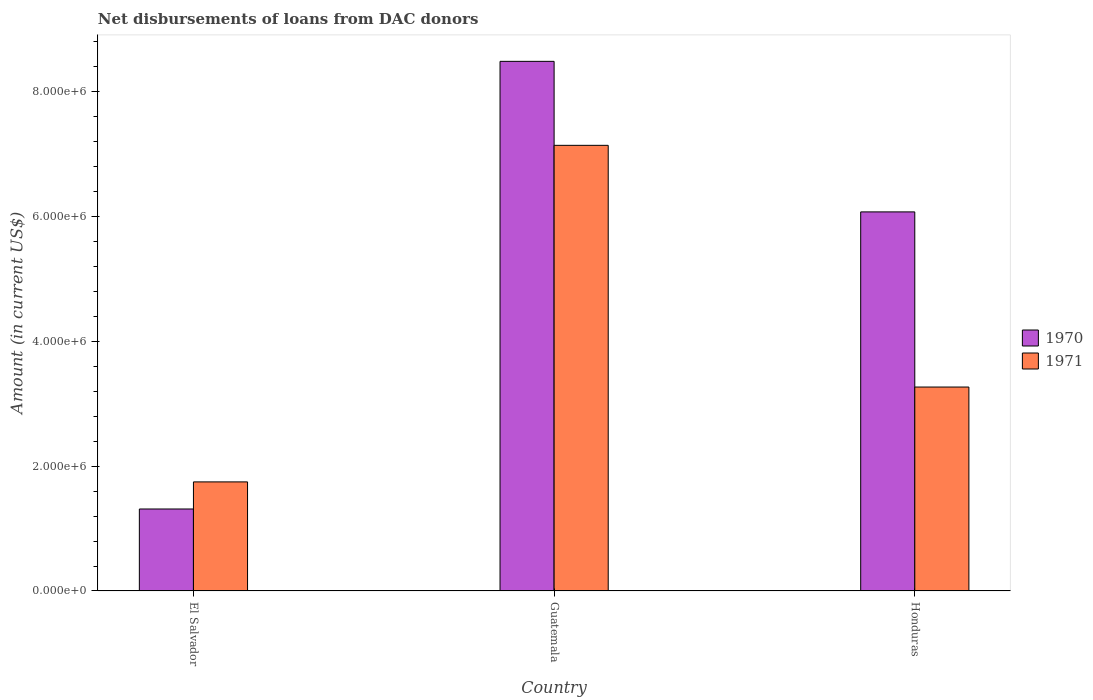How many different coloured bars are there?
Provide a succinct answer. 2. What is the label of the 3rd group of bars from the left?
Offer a terse response. Honduras. In how many cases, is the number of bars for a given country not equal to the number of legend labels?
Provide a short and direct response. 0. What is the amount of loans disbursed in 1971 in El Salvador?
Provide a short and direct response. 1.75e+06. Across all countries, what is the maximum amount of loans disbursed in 1970?
Your answer should be compact. 8.48e+06. Across all countries, what is the minimum amount of loans disbursed in 1970?
Provide a short and direct response. 1.31e+06. In which country was the amount of loans disbursed in 1971 maximum?
Your answer should be very brief. Guatemala. In which country was the amount of loans disbursed in 1970 minimum?
Give a very brief answer. El Salvador. What is the total amount of loans disbursed in 1970 in the graph?
Keep it short and to the point. 1.59e+07. What is the difference between the amount of loans disbursed in 1971 in El Salvador and that in Guatemala?
Provide a short and direct response. -5.39e+06. What is the difference between the amount of loans disbursed in 1971 in El Salvador and the amount of loans disbursed in 1970 in Guatemala?
Make the answer very short. -6.74e+06. What is the average amount of loans disbursed in 1971 per country?
Provide a succinct answer. 4.05e+06. What is the difference between the amount of loans disbursed of/in 1971 and amount of loans disbursed of/in 1970 in Guatemala?
Ensure brevity in your answer.  -1.34e+06. What is the ratio of the amount of loans disbursed in 1970 in El Salvador to that in Guatemala?
Make the answer very short. 0.15. Is the amount of loans disbursed in 1970 in El Salvador less than that in Honduras?
Your answer should be very brief. Yes. Is the difference between the amount of loans disbursed in 1971 in El Salvador and Honduras greater than the difference between the amount of loans disbursed in 1970 in El Salvador and Honduras?
Offer a terse response. Yes. What is the difference between the highest and the second highest amount of loans disbursed in 1971?
Give a very brief answer. 5.39e+06. What is the difference between the highest and the lowest amount of loans disbursed in 1971?
Offer a very short reply. 5.39e+06. What does the 1st bar from the right in El Salvador represents?
Ensure brevity in your answer.  1971. Are all the bars in the graph horizontal?
Offer a terse response. No. How many countries are there in the graph?
Provide a short and direct response. 3. Are the values on the major ticks of Y-axis written in scientific E-notation?
Your answer should be compact. Yes. What is the title of the graph?
Make the answer very short. Net disbursements of loans from DAC donors. What is the Amount (in current US$) in 1970 in El Salvador?
Ensure brevity in your answer.  1.31e+06. What is the Amount (in current US$) of 1971 in El Salvador?
Your response must be concise. 1.75e+06. What is the Amount (in current US$) in 1970 in Guatemala?
Make the answer very short. 8.48e+06. What is the Amount (in current US$) in 1971 in Guatemala?
Give a very brief answer. 7.14e+06. What is the Amount (in current US$) in 1970 in Honduras?
Your response must be concise. 6.07e+06. What is the Amount (in current US$) of 1971 in Honduras?
Ensure brevity in your answer.  3.27e+06. Across all countries, what is the maximum Amount (in current US$) of 1970?
Offer a very short reply. 8.48e+06. Across all countries, what is the maximum Amount (in current US$) of 1971?
Your answer should be compact. 7.14e+06. Across all countries, what is the minimum Amount (in current US$) of 1970?
Offer a very short reply. 1.31e+06. Across all countries, what is the minimum Amount (in current US$) in 1971?
Your answer should be compact. 1.75e+06. What is the total Amount (in current US$) of 1970 in the graph?
Keep it short and to the point. 1.59e+07. What is the total Amount (in current US$) in 1971 in the graph?
Make the answer very short. 1.22e+07. What is the difference between the Amount (in current US$) in 1970 in El Salvador and that in Guatemala?
Keep it short and to the point. -7.17e+06. What is the difference between the Amount (in current US$) in 1971 in El Salvador and that in Guatemala?
Provide a succinct answer. -5.39e+06. What is the difference between the Amount (in current US$) of 1970 in El Salvador and that in Honduras?
Provide a succinct answer. -4.76e+06. What is the difference between the Amount (in current US$) in 1971 in El Salvador and that in Honduras?
Your answer should be very brief. -1.52e+06. What is the difference between the Amount (in current US$) in 1970 in Guatemala and that in Honduras?
Provide a short and direct response. 2.41e+06. What is the difference between the Amount (in current US$) of 1971 in Guatemala and that in Honduras?
Your answer should be very brief. 3.87e+06. What is the difference between the Amount (in current US$) in 1970 in El Salvador and the Amount (in current US$) in 1971 in Guatemala?
Ensure brevity in your answer.  -5.82e+06. What is the difference between the Amount (in current US$) of 1970 in El Salvador and the Amount (in current US$) of 1971 in Honduras?
Provide a succinct answer. -1.95e+06. What is the difference between the Amount (in current US$) in 1970 in Guatemala and the Amount (in current US$) in 1971 in Honduras?
Your answer should be very brief. 5.22e+06. What is the average Amount (in current US$) in 1970 per country?
Offer a terse response. 5.29e+06. What is the average Amount (in current US$) in 1971 per country?
Make the answer very short. 4.05e+06. What is the difference between the Amount (in current US$) in 1970 and Amount (in current US$) in 1971 in El Salvador?
Keep it short and to the point. -4.34e+05. What is the difference between the Amount (in current US$) in 1970 and Amount (in current US$) in 1971 in Guatemala?
Provide a short and direct response. 1.34e+06. What is the difference between the Amount (in current US$) in 1970 and Amount (in current US$) in 1971 in Honduras?
Provide a short and direct response. 2.80e+06. What is the ratio of the Amount (in current US$) in 1970 in El Salvador to that in Guatemala?
Your answer should be compact. 0.15. What is the ratio of the Amount (in current US$) of 1971 in El Salvador to that in Guatemala?
Make the answer very short. 0.24. What is the ratio of the Amount (in current US$) of 1970 in El Salvador to that in Honduras?
Ensure brevity in your answer.  0.22. What is the ratio of the Amount (in current US$) of 1971 in El Salvador to that in Honduras?
Make the answer very short. 0.53. What is the ratio of the Amount (in current US$) of 1970 in Guatemala to that in Honduras?
Provide a succinct answer. 1.4. What is the ratio of the Amount (in current US$) in 1971 in Guatemala to that in Honduras?
Ensure brevity in your answer.  2.19. What is the difference between the highest and the second highest Amount (in current US$) of 1970?
Your response must be concise. 2.41e+06. What is the difference between the highest and the second highest Amount (in current US$) in 1971?
Keep it short and to the point. 3.87e+06. What is the difference between the highest and the lowest Amount (in current US$) of 1970?
Ensure brevity in your answer.  7.17e+06. What is the difference between the highest and the lowest Amount (in current US$) of 1971?
Keep it short and to the point. 5.39e+06. 